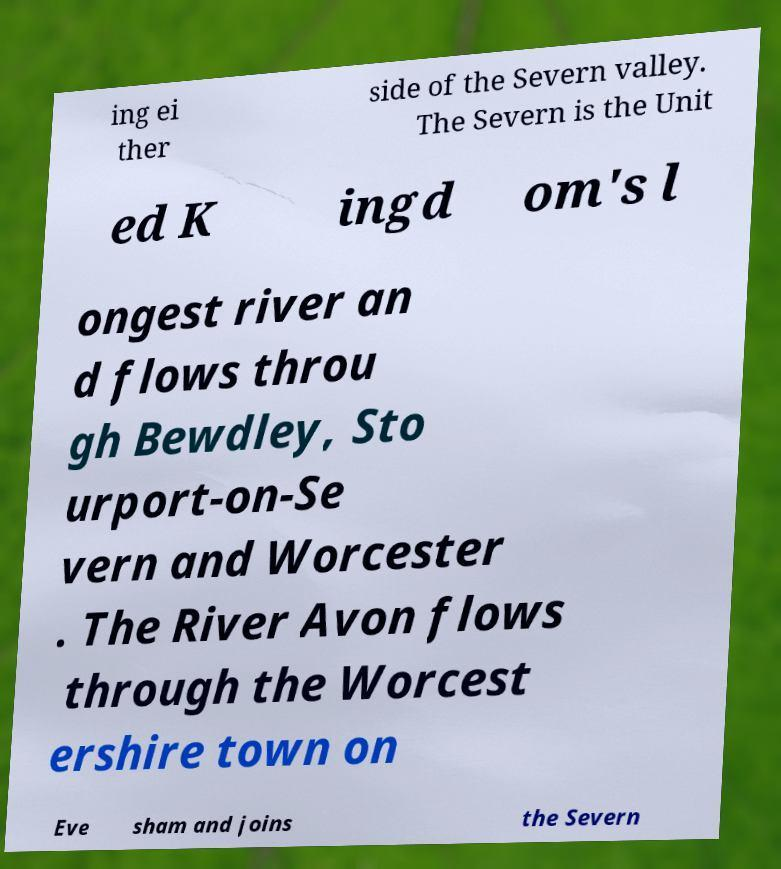What messages or text are displayed in this image? I need them in a readable, typed format. ing ei ther side of the Severn valley. The Severn is the Unit ed K ingd om's l ongest river an d flows throu gh Bewdley, Sto urport-on-Se vern and Worcester . The River Avon flows through the Worcest ershire town on Eve sham and joins the Severn 